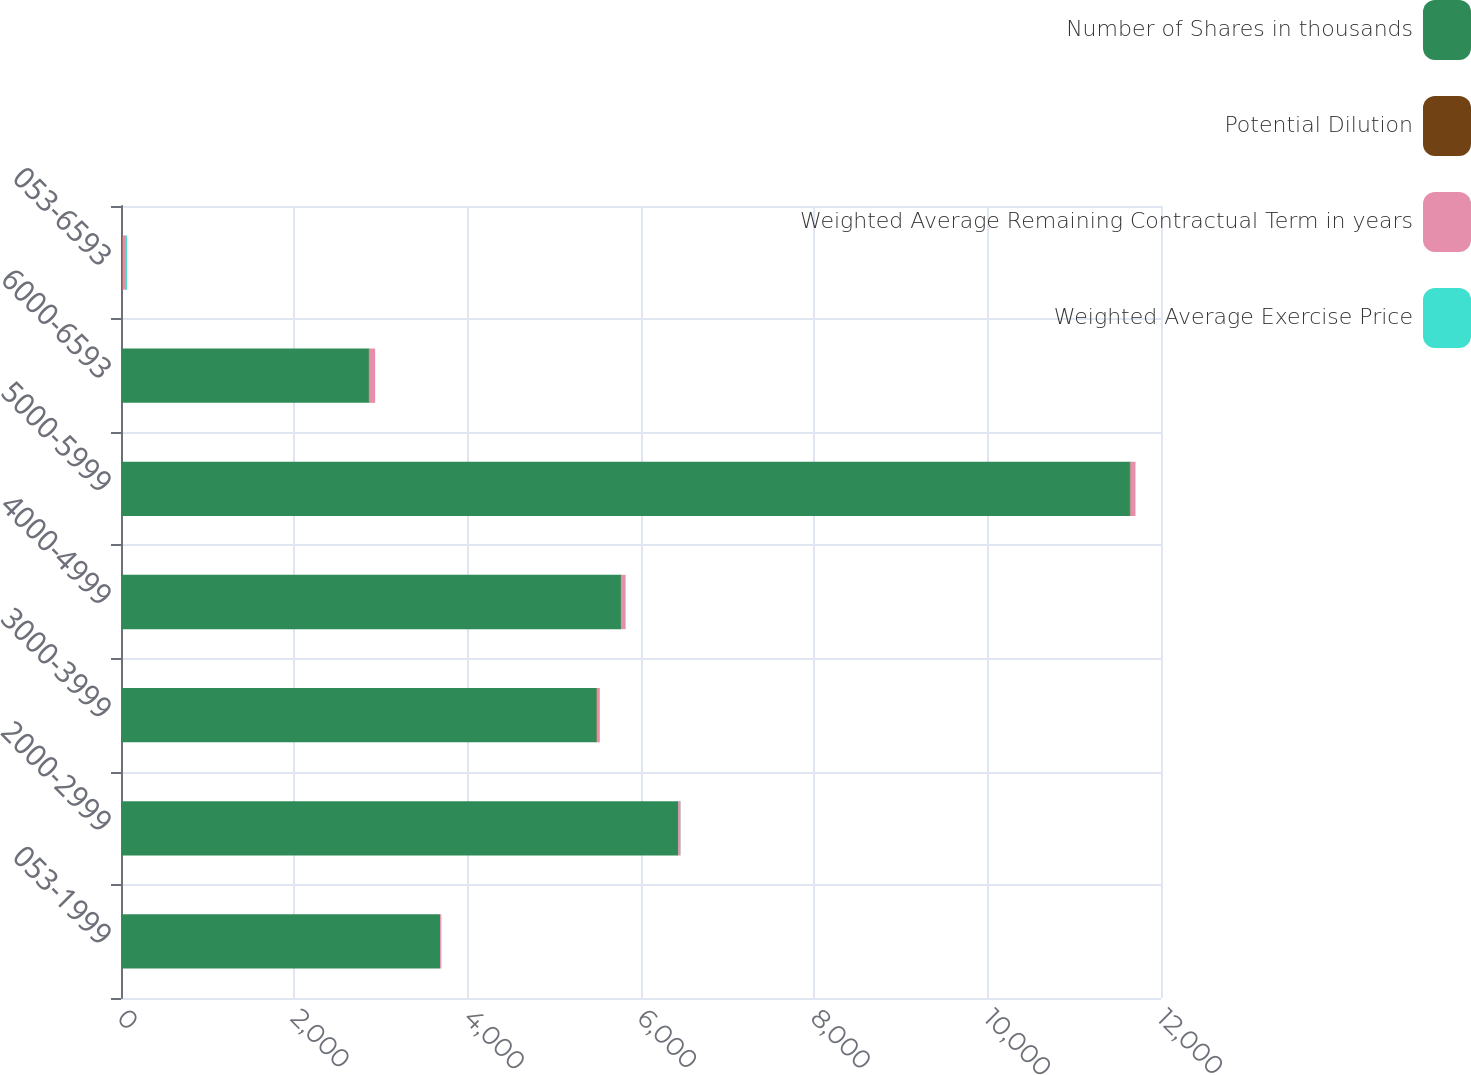<chart> <loc_0><loc_0><loc_500><loc_500><stacked_bar_chart><ecel><fcel>053-1999<fcel>2000-2999<fcel>3000-3999<fcel>4000-4999<fcel>5000-5999<fcel>6000-6593<fcel>053-6593<nl><fcel>Number of Shares in thousands<fcel>3681<fcel>6427<fcel>5487<fcel>5768<fcel>11641<fcel>2860<fcel>11.5<nl><fcel>Potential Dilution<fcel>1.72<fcel>4.26<fcel>5.35<fcel>6.87<fcel>8.37<fcel>7.82<fcel>6.2<nl><fcel>Weighted Average Remaining Contractual Term in years<fcel>12.42<fcel>25.37<fcel>31.83<fcel>46.88<fcel>53.62<fcel>64.17<fcel>40.75<nl><fcel>Weighted Average Exercise Price<fcel>1.2<fcel>2.1<fcel>1.8<fcel>1.8<fcel>3.7<fcel>0.9<fcel>11.5<nl></chart> 